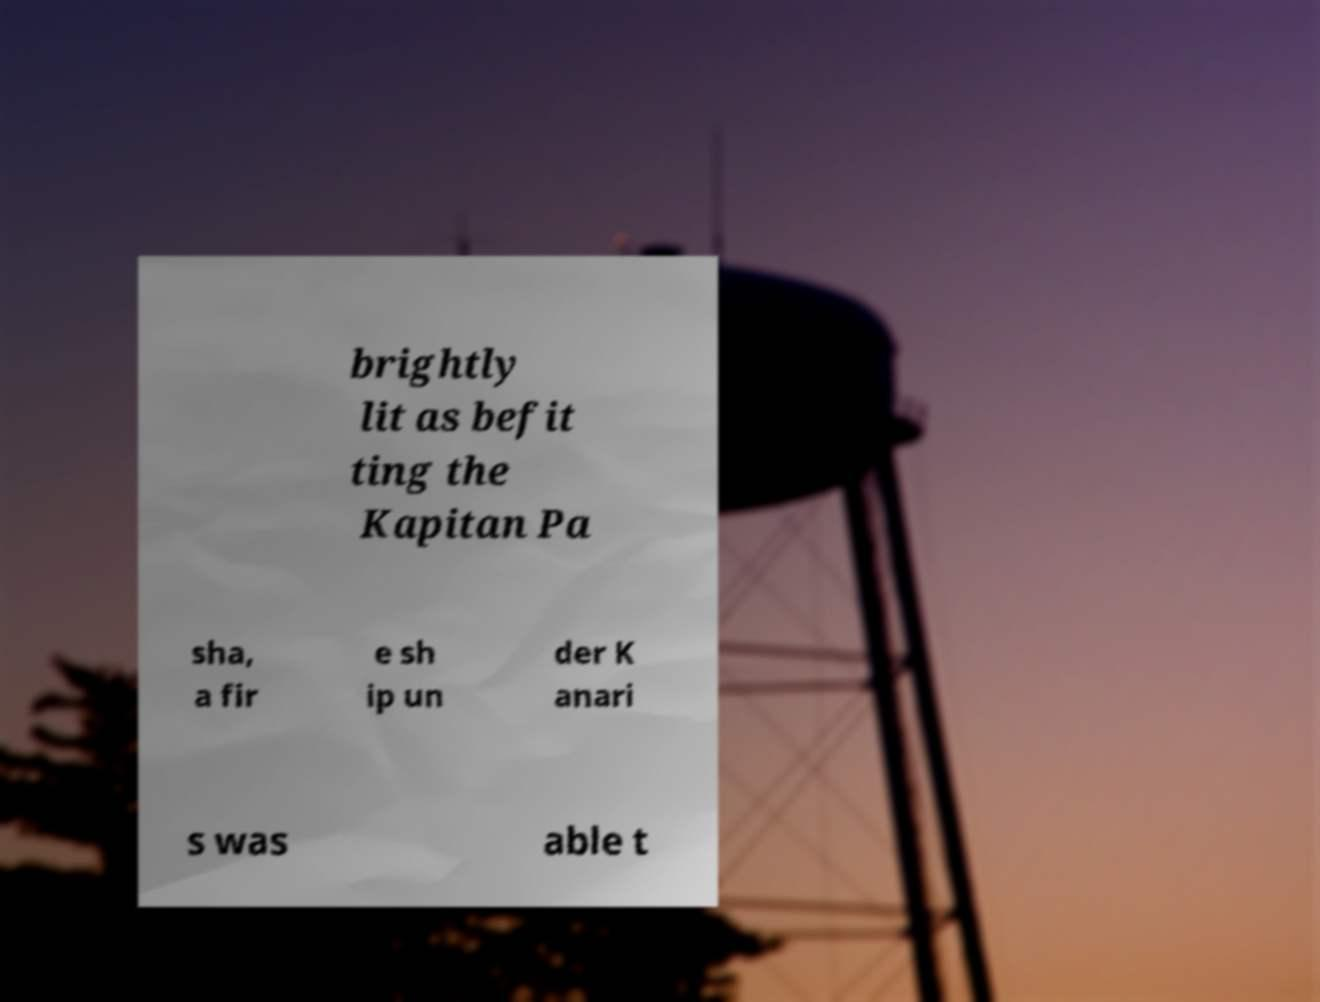Can you read and provide the text displayed in the image?This photo seems to have some interesting text. Can you extract and type it out for me? brightly lit as befit ting the Kapitan Pa sha, a fir e sh ip un der K anari s was able t 